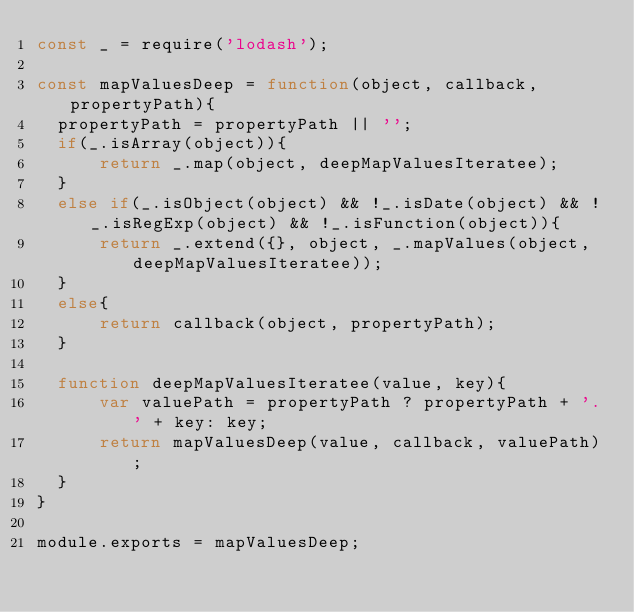Convert code to text. <code><loc_0><loc_0><loc_500><loc_500><_JavaScript_>const _ = require('lodash');

const mapValuesDeep = function(object, callback, propertyPath){
  propertyPath = propertyPath || '';
  if(_.isArray(object)){
      return _.map(object, deepMapValuesIteratee);
  }
  else if(_.isObject(object) && !_.isDate(object) && !_.isRegExp(object) && !_.isFunction(object)){
      return _.extend({}, object, _.mapValues(object, deepMapValuesIteratee));
  }
  else{
      return callback(object, propertyPath);
  }

  function deepMapValuesIteratee(value, key){
      var valuePath = propertyPath ? propertyPath + '.' + key: key;
      return mapValuesDeep(value, callback, valuePath);
  }
}

module.exports = mapValuesDeep;
</code> 